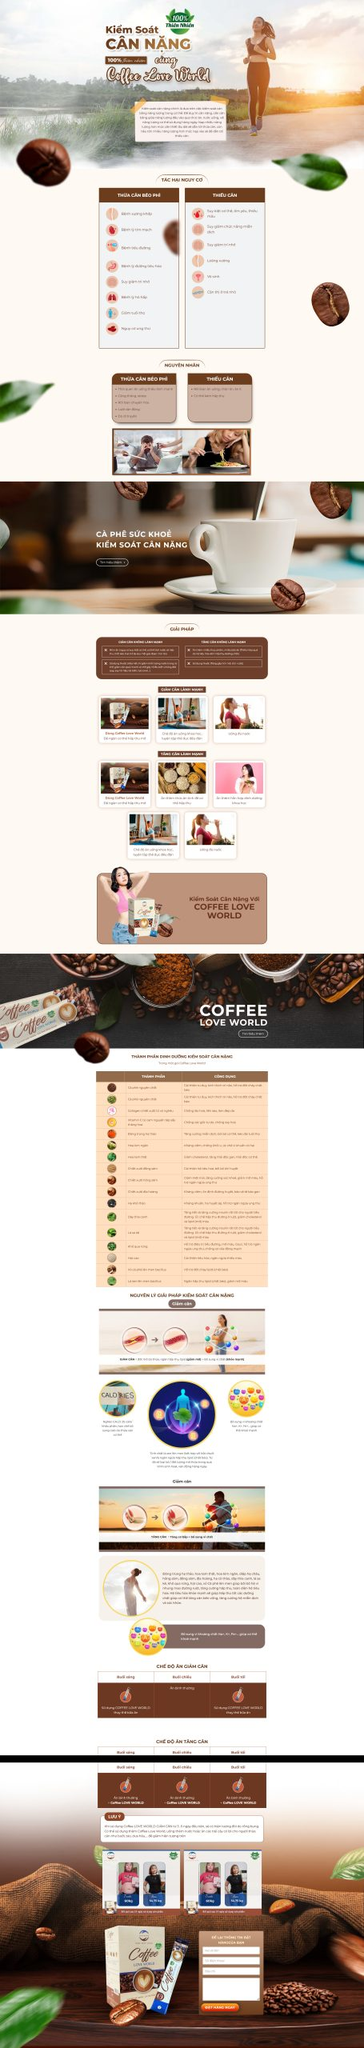Liệt kê 5 ngành nghề, lĩnh vực phù hợp với website này, phân cách các màu sắc bằng dấu phẩy. Chỉ trả về kết quả, phân cách bằng dấy phẩy
 giảm cân, chăm sóc sức khỏe, thể thao, dinh dưỡng, thực phẩm chức năng 